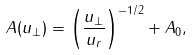Convert formula to latex. <formula><loc_0><loc_0><loc_500><loc_500>A ( u _ { \perp } ) = \left ( \frac { u _ { \perp } } { u _ { r } } \right ) ^ { - 1 / 2 } + A _ { 0 } ,</formula> 